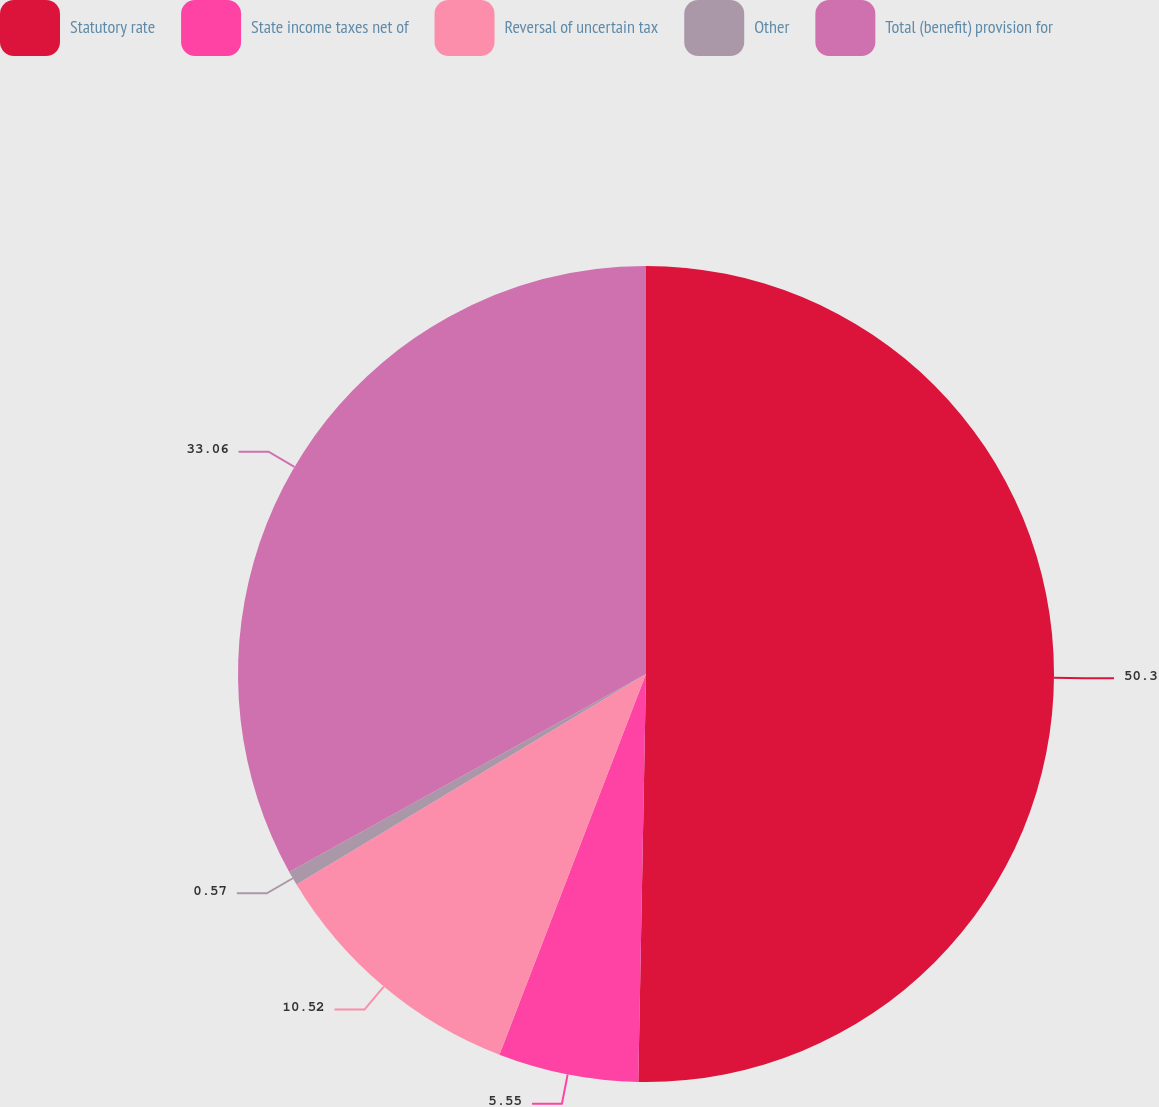Convert chart to OTSL. <chart><loc_0><loc_0><loc_500><loc_500><pie_chart><fcel>Statutory rate<fcel>State income taxes net of<fcel>Reversal of uncertain tax<fcel>Other<fcel>Total (benefit) provision for<nl><fcel>50.3%<fcel>5.55%<fcel>10.52%<fcel>0.57%<fcel>33.06%<nl></chart> 